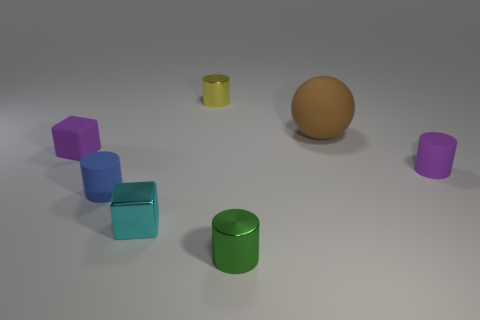What is the color of the matte cylinder in front of the purple object on the right side of the metal cylinder in front of the large rubber thing? The cylinder positioned in front of the purple object and on the right of the metal cylinder is blue. Its matte texture distinguishes it from the shinier objects, and it stands out against the neutral background. 